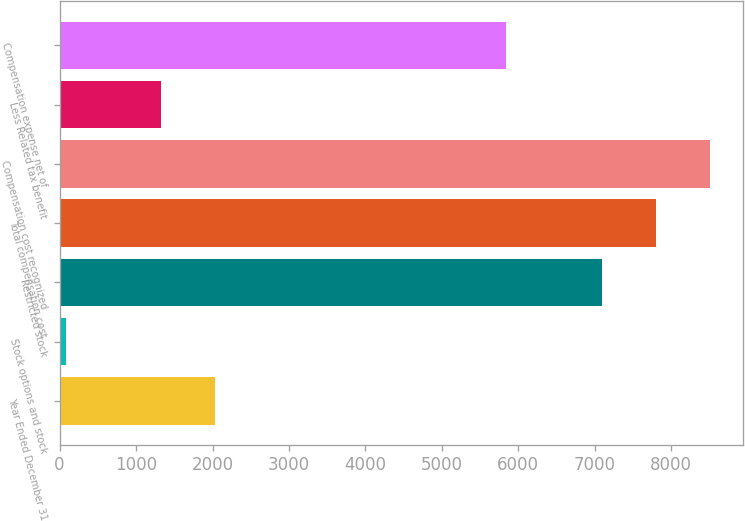Convert chart to OTSL. <chart><loc_0><loc_0><loc_500><loc_500><bar_chart><fcel>Year Ended December 31<fcel>Stock options and stock<fcel>Restricted stock<fcel>Total compensation cost<fcel>Compensation cost recognized<fcel>Less Related tax benefit<fcel>Compensation expense net of<nl><fcel>2035.2<fcel>78<fcel>7092<fcel>7801.2<fcel>8510.4<fcel>1326<fcel>5844<nl></chart> 